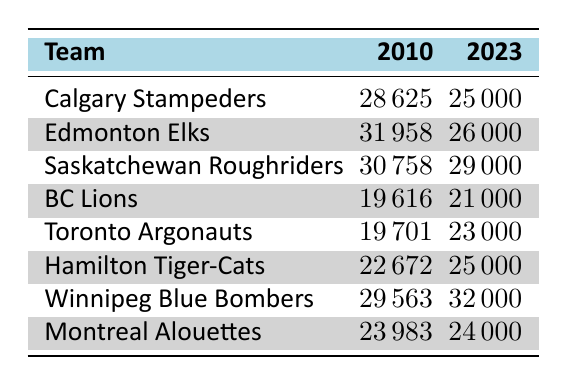What is the average attendance for the Calgary Stampeders in 2010? Looking at the table, the average attendance for the Calgary Stampeders in 2010 is directly listed as 28625.
Answer: 28625 Which team had the highest average attendance in 2010? By examining the 2010 attendance figures, the Edmonton Elks had the highest number with an average of 31958.
Answer: Edmonton Elks Is it true that the average attendance for the Saskatchewan Roughriders increased from 2010 to 2023? In 2010, the Saskatchewan Roughriders had an average attendance of 30758, and in 2023, it decreased to 29000. Therefore, the statement is false.
Answer: No What is the difference in average attendance for the Winnipeg Blue Bombers between 2010 and 2023? The average attendance for the Winnipeg Blue Bombers in 2010 was 29563, while in 2023 it is 32000. The difference is calculated as 32000 - 29563 = 1437.
Answer: 1437 What is the total average attendance across all teams in 2023? To find the total average attendance for 2023, we will sum the attendance figures for all teams: 25000 + 26000 + 29000 + 21000 + 23000 + 25000 + 32000 + 24000 = 201000.
Answer: 201000 Did the average attendance for the BC Lions in 2023 surpass their 2010 average? The average attendance for the BC Lions in 2010 was 19616, and in 2023 it increased to 21000. Since 21000 > 19616, the statement is true.
Answer: Yes Which team had the smallest increase in attendance from 2010 to 2023? The increases for each team can be calculated: Calgary Stampeders (25000 - 28625 = -3625), Edmonton Elks (26000 - 31958 = -5958), Saskatchewan Roughriders (29000 - 30758 = -1758), BC Lions (21000 - 19616 = 1384), Toronto Argonauts (23000 - 19701 = 3299), Hamilton Tiger-Cats (25000 - 22672 = 1328), Winnipeg Blue Bombers (32000 - 29563 = 1437), and Montreal Alouettes (24000 - 23983 = 17). The smallest positive increase was for the BC Lions.
Answer: BC Lions How many teams had an average attendance of over 30000 in 2010? From the data, we count the teams with average attendance exceeding 30000 in 2010: Calgary Stampeders (28625), Edmonton Elks (31958), Saskatchewan Roughriders (30758), BC Lions (19616), Toronto Argonauts (19701), Hamilton Tiger-Cats (22672), Winnipeg Blue Bombers (29563), Montreal Alouettes (23983). Only 1 team had over 30000 attendance in 2010, which is Edmonton Elks.
Answer: 1 